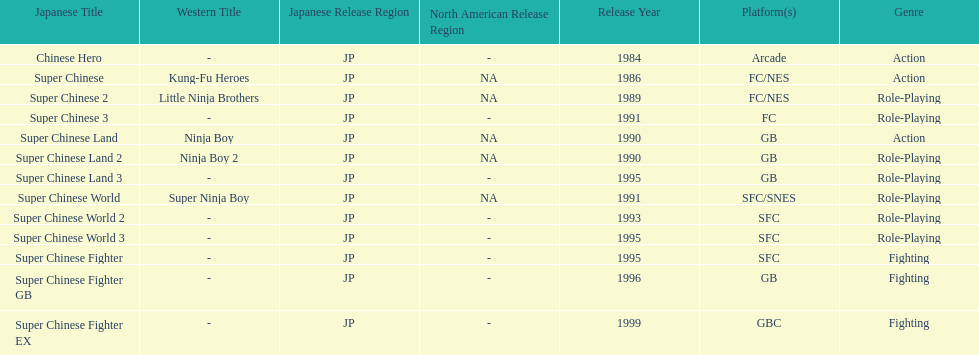The first year a game was released in north america 1986. 